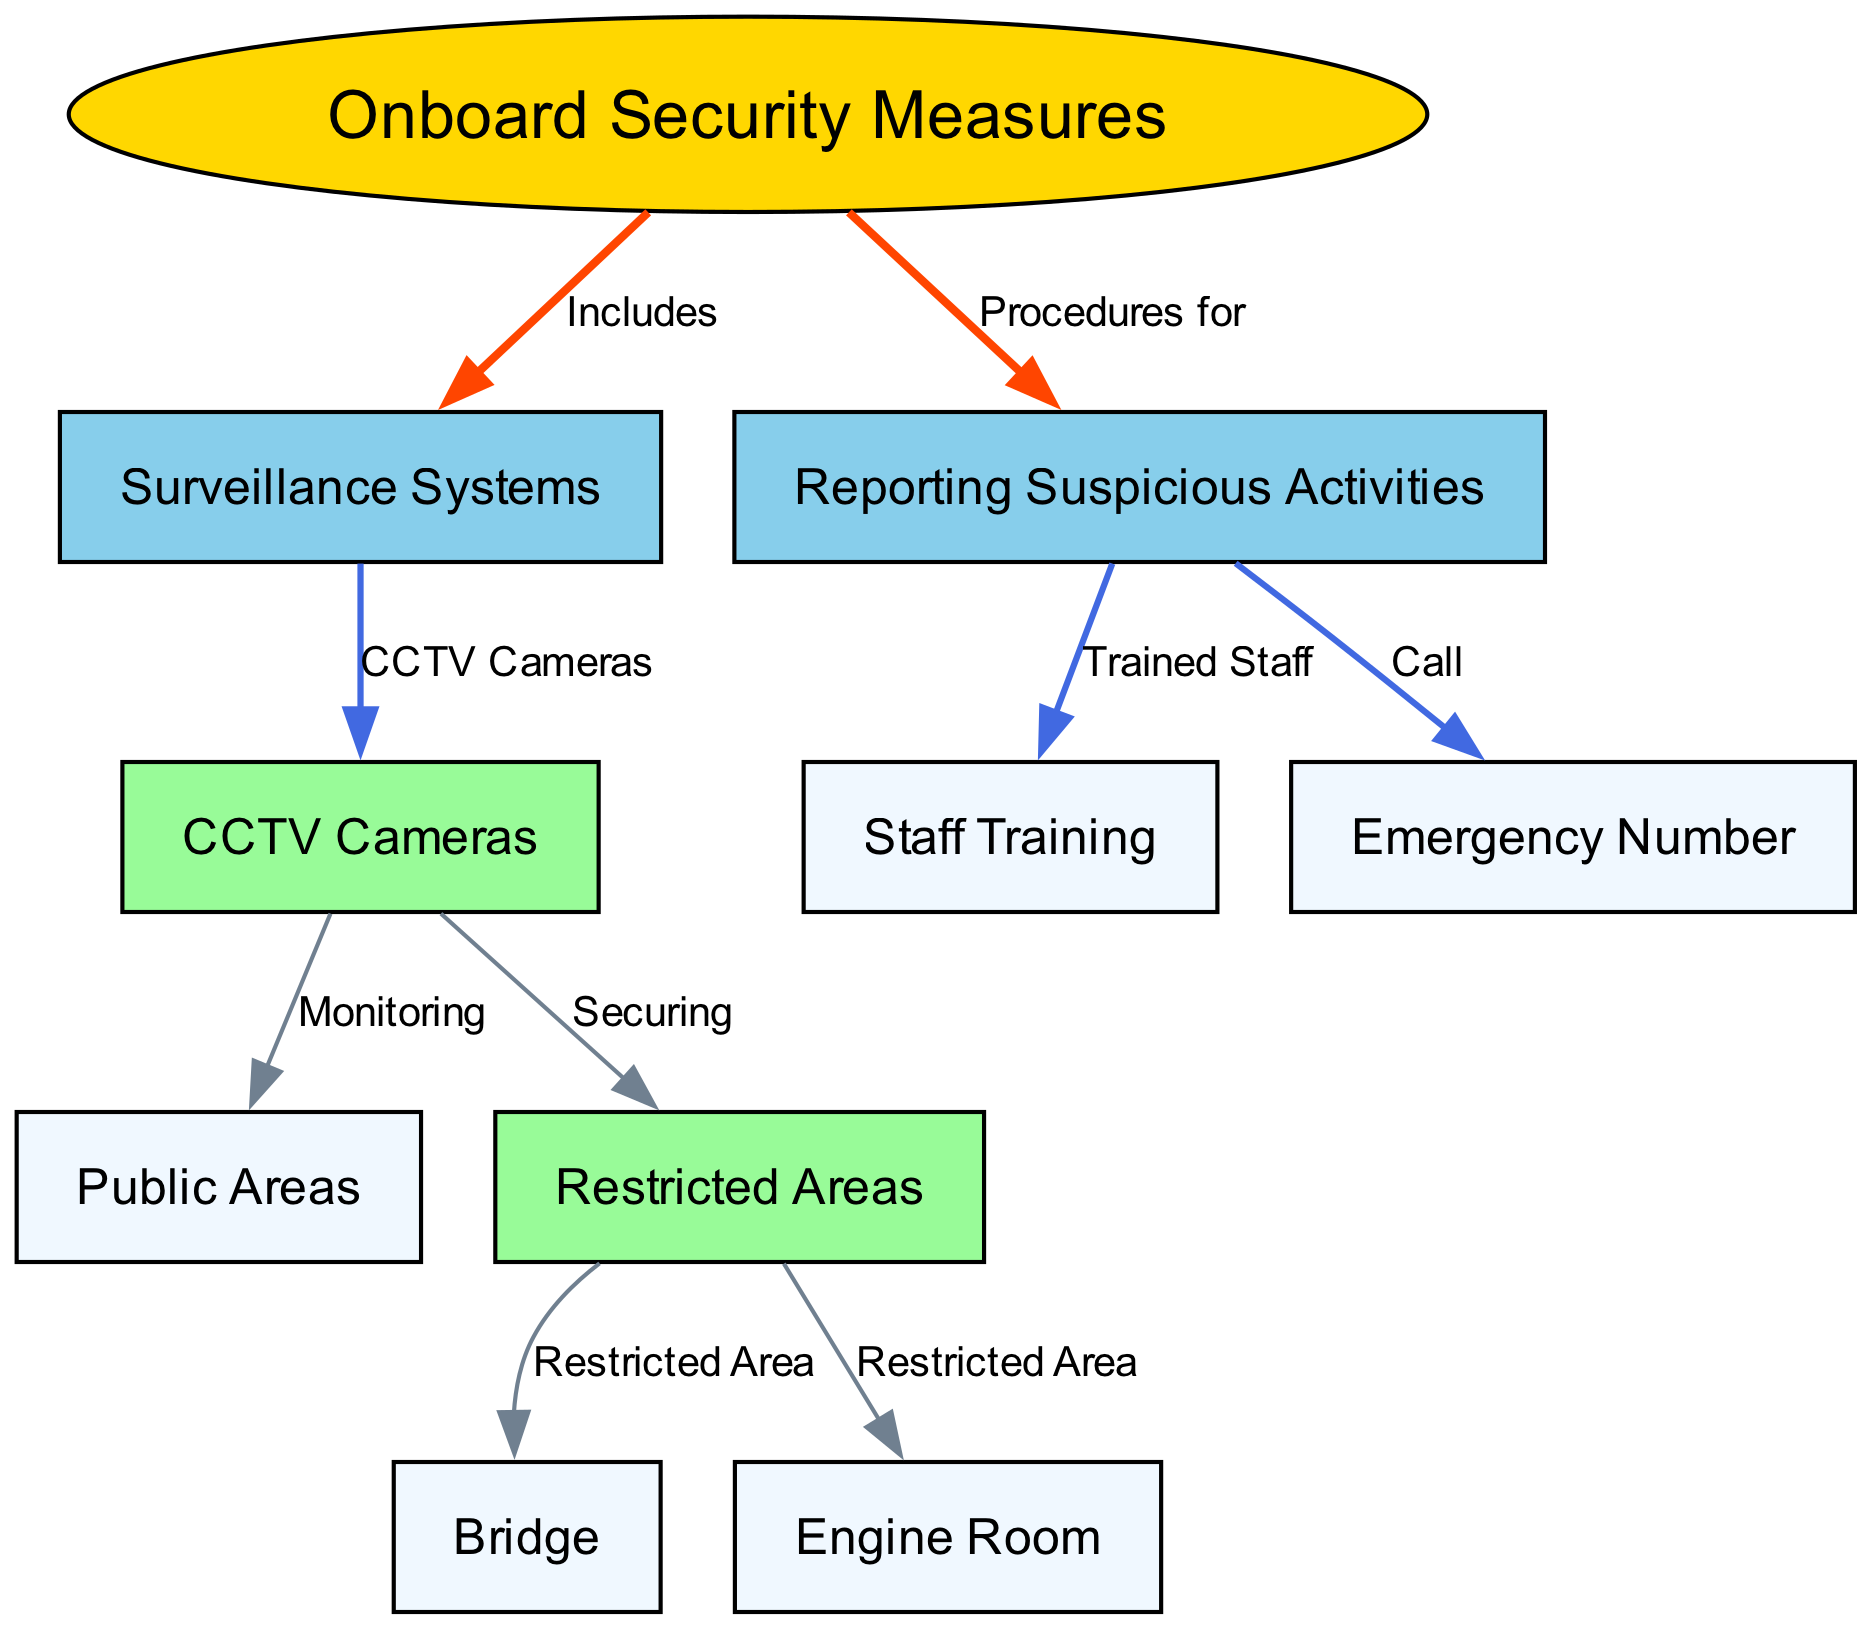What does the "Onboard Security Measures" node include? The "Onboard Security Measures" node includes the "Surveillance Systems" and "Reporting Suspicious Activities" nodes, as indicated by the outgoing edges from the security measures node.
Answer: Surveillance Systems, Reporting Suspicious Activities How many nodes are connected to "Surveillance Systems"? "Surveillance Systems" is connected to two nodes: "CCTV Cameras" and "reporting suspicious activities". This means there are two direct connections.
Answer: 2 What areas are categorized as "Restricted Areas"? The "Restricted Areas" node branches out to two specific areas, namely the "Bridge" and the "Engine Room", indicating these are the restricted areas onboard.
Answer: Bridge, Engine Room Which system monitors public areas? The system that monitors public areas is indicated by the "CCTV Cameras" node, which connects to "Public Areas" from the diagram.
Answer: CCTV Cameras What number should you call for reporting suspicious activities? According to the diagram, the procedure for reporting suspicious activities entails calling the "Emergency Number" node, which is directly connected to "Reporting Suspicious Activities".
Answer: Emergency Number How are suspicious activities reported? Reporting suspicious activities involves trained staff and calling an emergency number, which is outlined in the connections stemming from the "Reporting Suspicious Activities" node.
Answer: Trained Staff, Call Emergency Number Which areas are monitored by CCTV cameras? The CCTV cameras specifically monitor "Public Areas" and secure "Restricted Areas", as shown by the connections in the diagram from "CCTV Cameras".
Answer: Public Areas, Restricted Areas What training is provided regarding suspicious activities? The diagram indicates that "Staff Training" is linked to the "Reporting Suspicious Activities" node, showing that staff are trained to handle these situations.
Answer: Staff Training 